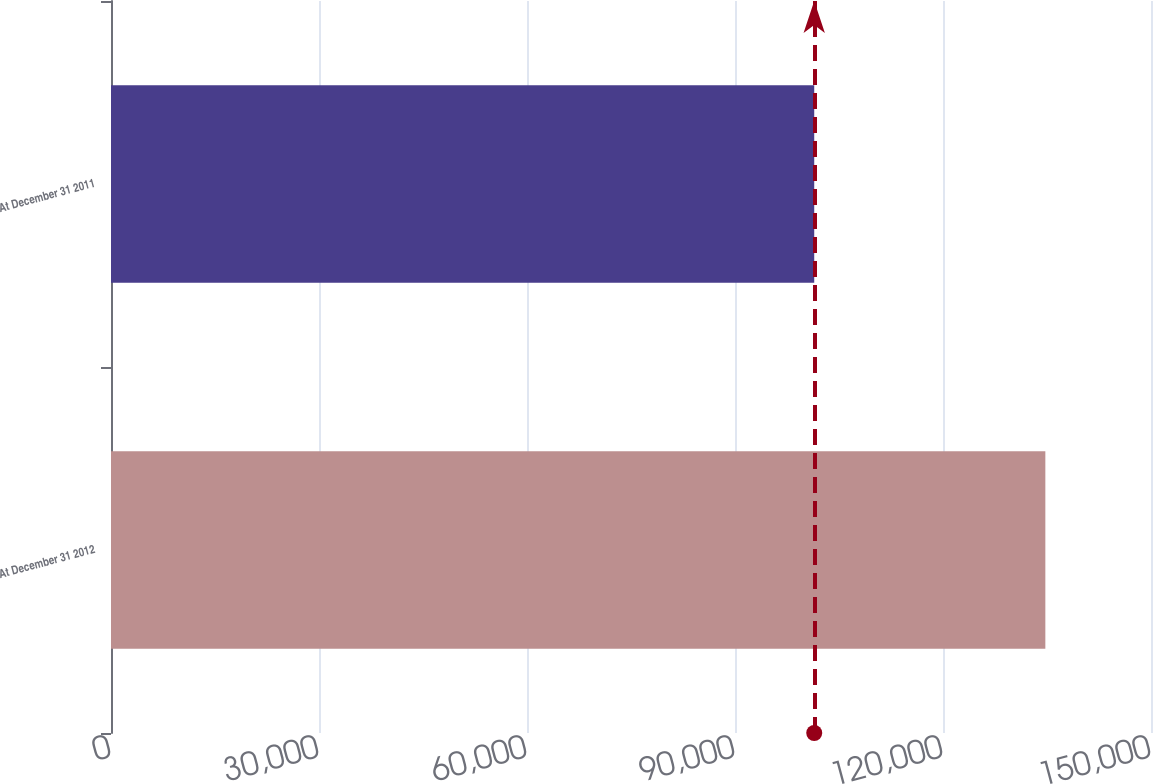<chart> <loc_0><loc_0><loc_500><loc_500><bar_chart><fcel>At December 31 2012<fcel>At December 31 2011<nl><fcel>134762<fcel>101427<nl></chart> 